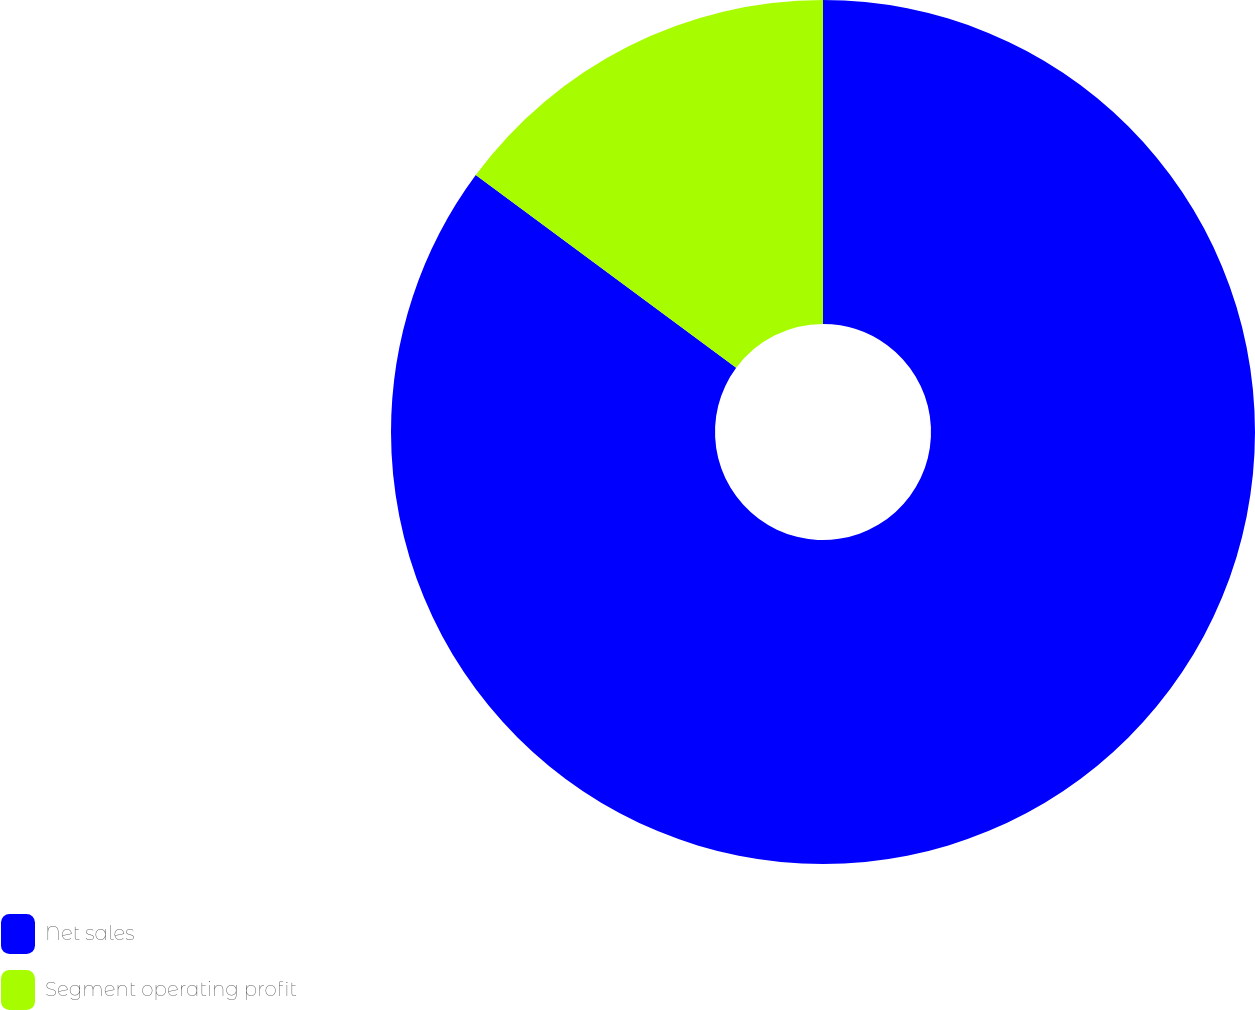Convert chart. <chart><loc_0><loc_0><loc_500><loc_500><pie_chart><fcel>Net sales<fcel>Segment operating profit<nl><fcel>85.14%<fcel>14.86%<nl></chart> 